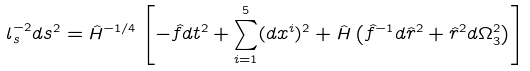<formula> <loc_0><loc_0><loc_500><loc_500>l _ { s } ^ { - 2 } d s ^ { 2 } = \hat { H } ^ { - 1 / 4 } \left [ - \hat { f } d t ^ { 2 } + \sum _ { i = 1 } ^ { 5 } ( d x ^ { i } ) ^ { 2 } + \hat { H } \left ( \hat { f } ^ { - 1 } d \hat { r } ^ { 2 } + \hat { r } ^ { 2 } d \Omega _ { 3 } ^ { 2 } \right ) \right ]</formula> 